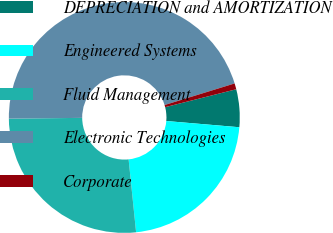Convert chart to OTSL. <chart><loc_0><loc_0><loc_500><loc_500><pie_chart><fcel>DEPRECIATION and AMORTIZATION<fcel>Engineered Systems<fcel>Fluid Management<fcel>Electronic Technologies<fcel>Corporate<nl><fcel>5.28%<fcel>22.02%<fcel>26.47%<fcel>45.4%<fcel>0.83%<nl></chart> 